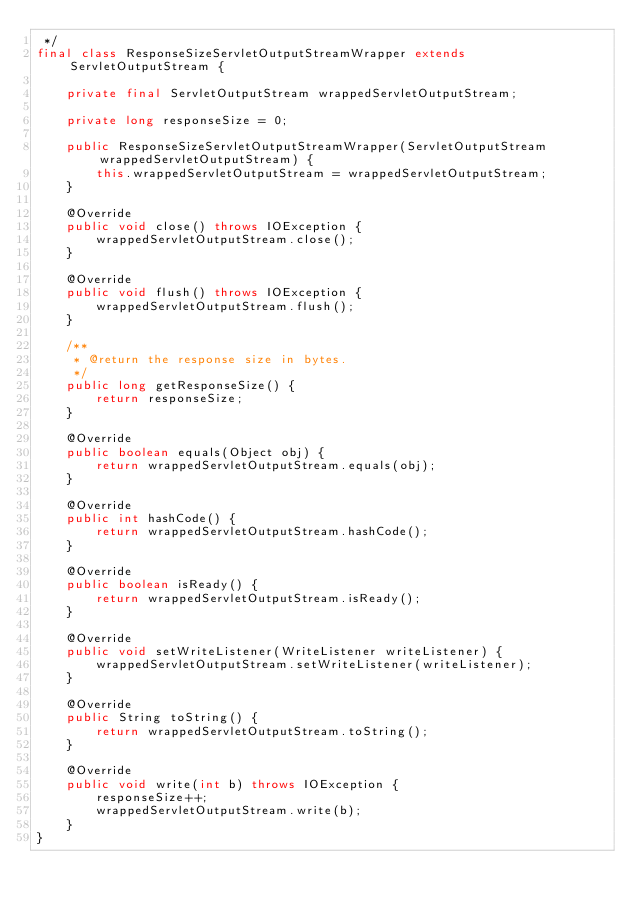<code> <loc_0><loc_0><loc_500><loc_500><_Java_> */
final class ResponseSizeServletOutputStreamWrapper extends ServletOutputStream {

    private final ServletOutputStream wrappedServletOutputStream;

    private long responseSize = 0;

    public ResponseSizeServletOutputStreamWrapper(ServletOutputStream wrappedServletOutputStream) {
        this.wrappedServletOutputStream = wrappedServletOutputStream;
    }

    @Override
    public void close() throws IOException {
        wrappedServletOutputStream.close();
    }

    @Override
    public void flush() throws IOException {
        wrappedServletOutputStream.flush();
    }

    /**
     * @return the response size in bytes.
     */
    public long getResponseSize() {
        return responseSize;
    }

    @Override
    public boolean equals(Object obj) {
        return wrappedServletOutputStream.equals(obj);
    }

    @Override
    public int hashCode() {
        return wrappedServletOutputStream.hashCode();
    }

    @Override
    public boolean isReady() {
        return wrappedServletOutputStream.isReady();
    }

    @Override
    public void setWriteListener(WriteListener writeListener) {
        wrappedServletOutputStream.setWriteListener(writeListener);
    }

    @Override
    public String toString() {
        return wrappedServletOutputStream.toString();
    }

    @Override
    public void write(int b) throws IOException {
        responseSize++;
        wrappedServletOutputStream.write(b);
    }
}
</code> 